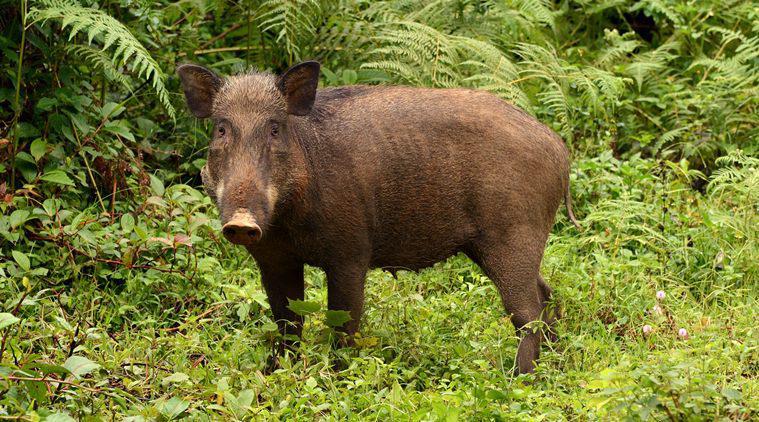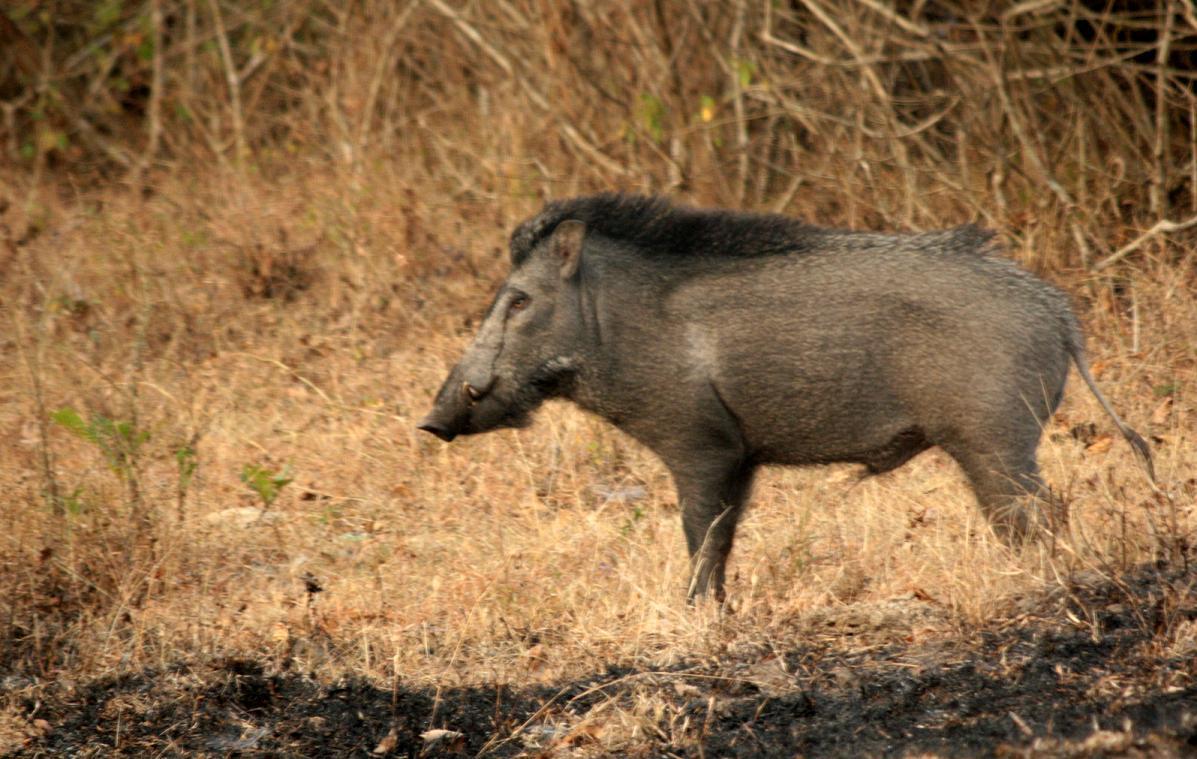The first image is the image on the left, the second image is the image on the right. Assess this claim about the two images: "Both animals are standing in a field.". Correct or not? Answer yes or no. Yes. The first image is the image on the left, the second image is the image on the right. Considering the images on both sides, is "The boar in the right image is standing in green foliage." valid? Answer yes or no. No. 